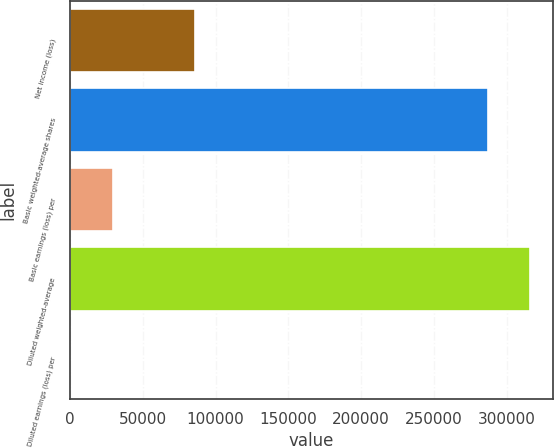Convert chart to OTSL. <chart><loc_0><loc_0><loc_500><loc_500><bar_chart><fcel>Net income (loss)<fcel>Basic weighted-average shares<fcel>Basic earnings (loss) per<fcel>Diluted weighted-average<fcel>Diluted earnings (loss) per<nl><fcel>86012<fcel>286991<fcel>29259.2<fcel>316250<fcel>0.29<nl></chart> 